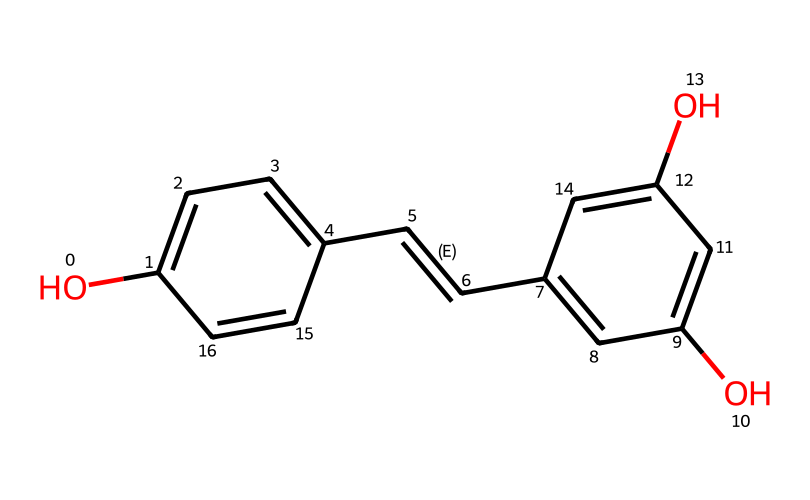What is the chemical name of the structure represented by the SMILES? The SMILES provided corresponds to a compound that is specifically known as resveratrol, which is a phenolic compound.
Answer: resveratrol How many hydroxyl (–OH) groups are present in resveratrol? By analyzing the structure, we can identify two distinct hydroxyl groups attached to the aromatic rings.
Answer: 2 What is the total number of carbon atoms in resveratrol? By counting the carbon atoms depicted in the structure, including those in the aromatic and alkenyl parts, we identify a total of 14 carbon atoms.
Answer: 14 Does resveratrol contain any double bonds? The structure of resveratrol shows a double bond between the two carbon atoms in the alkenyl group, which is characteristic of the compound.
Answer: yes What type of antioxidant is resveratrol classified as? Resveratrol is known to be a polyphenolic antioxidant, which provides it with its antioxidant properties.
Answer: polyphenol How many rings are present in the structure of resveratrol? The chemical structure shows that there are two benzene rings within its structure, indicating the presence of two distinct rings.
Answer: 2 What role do the hydroxyl groups play in resveratrol's functionality? The hydroxyl groups in resveratrol are significant for its antioxidant activity, as they donate hydrogen atoms to free radicals, effectively neutralizing them.
Answer: antioxidant activity 